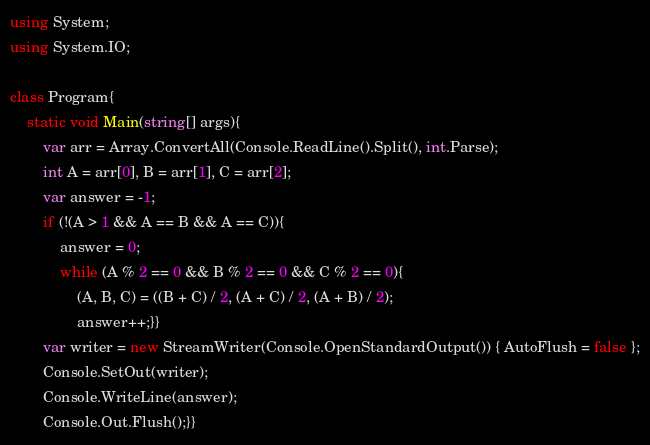<code> <loc_0><loc_0><loc_500><loc_500><_C#_>using System;
using System.IO;

class Program{
    static void Main(string[] args){
        var arr = Array.ConvertAll(Console.ReadLine().Split(), int.Parse);
        int A = arr[0], B = arr[1], C = arr[2];
        var answer = -1;
        if (!(A > 1 && A == B && A == C)){
            answer = 0;
            while (A % 2 == 0 && B % 2 == 0 && C % 2 == 0){
                (A, B, C) = ((B + C) / 2, (A + C) / 2, (A + B) / 2);
                answer++;}}
        var writer = new StreamWriter(Console.OpenStandardOutput()) { AutoFlush = false };
        Console.SetOut(writer);
        Console.WriteLine(answer);
        Console.Out.Flush();}}</code> 